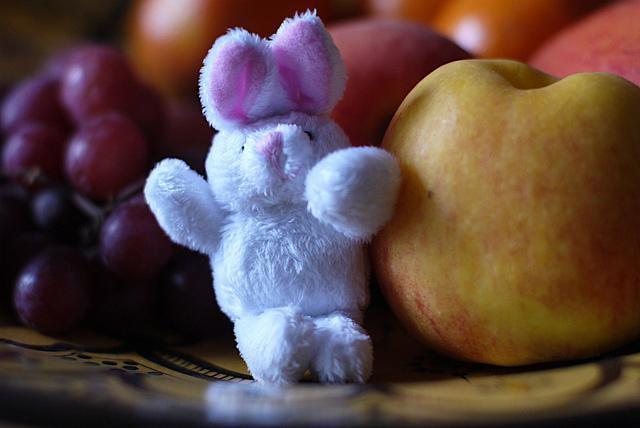Does the caption "The teddy bear is at the right side of the apple." correctly depict the image?
Answer yes or no. No. Is "The teddy bear is right of the apple." an appropriate description for the image?
Answer yes or no. No. 